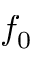Convert formula to latex. <formula><loc_0><loc_0><loc_500><loc_500>f _ { 0 }</formula> 